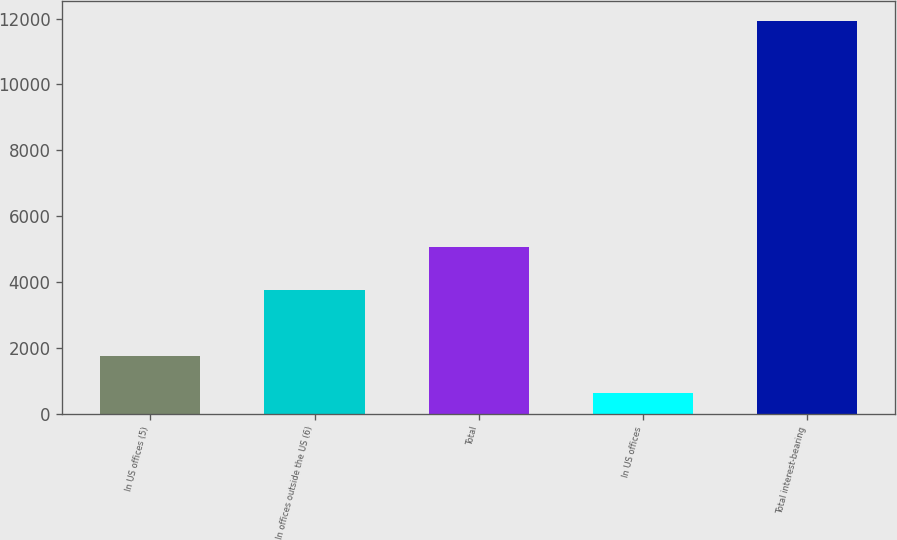Convert chart to OTSL. <chart><loc_0><loc_0><loc_500><loc_500><bar_chart><fcel>In US offices (5)<fcel>In offices outside the US (6)<fcel>Total<fcel>In US offices<fcel>Total interest-bearing<nl><fcel>1744.7<fcel>3761<fcel>5052<fcel>614<fcel>11921<nl></chart> 